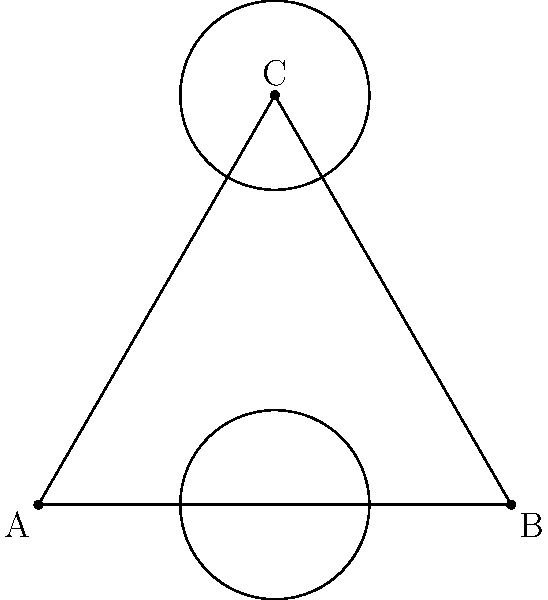In a symmetrical game map designed as an equilateral triangle, consider the dihedral group $D_3$ of its symmetries. If a power-up is placed at vertex C and another at the midpoint of side AB, how many unique configurations can be created by applying the symmetries of $D_3$? Let's approach this step-by-step:

1) The dihedral group $D_3$ has 6 elements: 3 rotations and 3 reflections.

2) We need to consider how these symmetries affect the positions of the two power-ups:
   - The power-up at vertex C
   - The power-up at the midpoint of side AB

3) Let's examine the effect of each symmetry:
   - Identity: No change
   - Rotation by 120°: C moves to A, midpoint of AB moves to midpoint of BC
   - Rotation by 240°: C moves to B, midpoint of AB moves to midpoint of AC
   - Reflection across AC: C stays at C, midpoint of AB moves to midpoint of BC
   - Reflection across BC: C moves to A, midpoint of AB stays at midpoint of AB
   - Reflection across AB: C moves to B, midpoint of AB stays at midpoint of AB

4) Looking at these outcomes, we can see that there are only 3 unique configurations:
   - Power-ups at C and midpoint of AB
   - Power-ups at A and midpoint of BC
   - Power-ups at B and midpoint of AC

5) All other symmetries in $D_3$ result in one of these three configurations.

Therefore, despite having 6 symmetries in $D_3$, there are only 3 unique configurations possible.
Answer: 3 unique configurations 